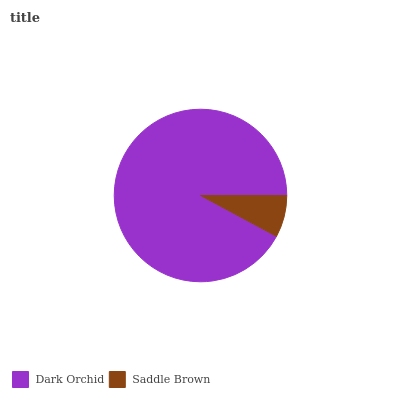Is Saddle Brown the minimum?
Answer yes or no. Yes. Is Dark Orchid the maximum?
Answer yes or no. Yes. Is Saddle Brown the maximum?
Answer yes or no. No. Is Dark Orchid greater than Saddle Brown?
Answer yes or no. Yes. Is Saddle Brown less than Dark Orchid?
Answer yes or no. Yes. Is Saddle Brown greater than Dark Orchid?
Answer yes or no. No. Is Dark Orchid less than Saddle Brown?
Answer yes or no. No. Is Dark Orchid the high median?
Answer yes or no. Yes. Is Saddle Brown the low median?
Answer yes or no. Yes. Is Saddle Brown the high median?
Answer yes or no. No. Is Dark Orchid the low median?
Answer yes or no. No. 